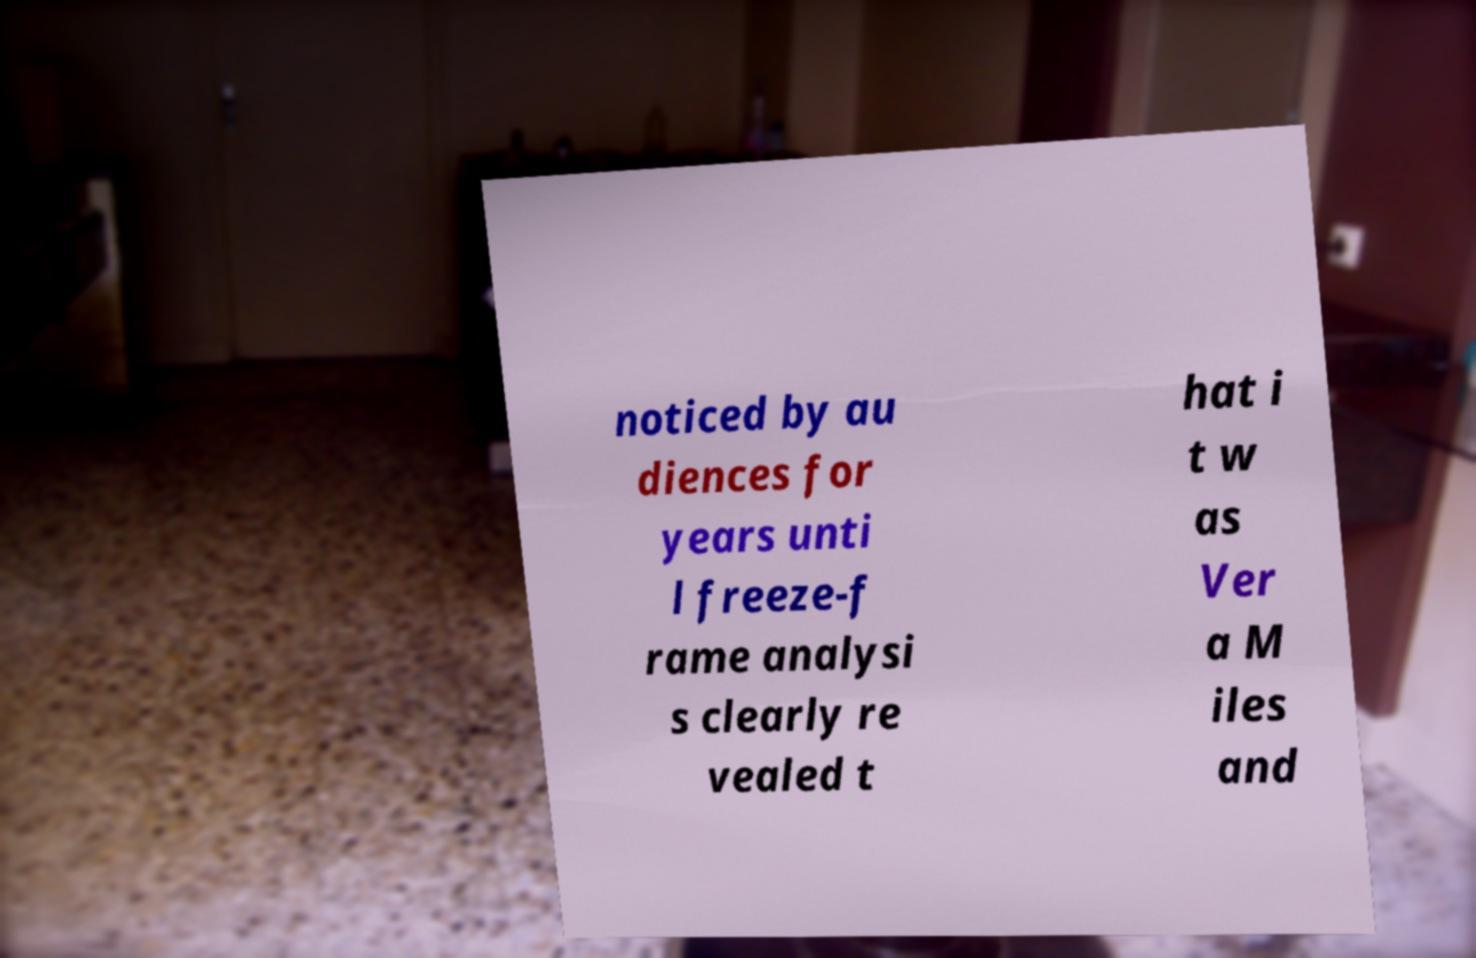What messages or text are displayed in this image? I need them in a readable, typed format. noticed by au diences for years unti l freeze-f rame analysi s clearly re vealed t hat i t w as Ver a M iles and 